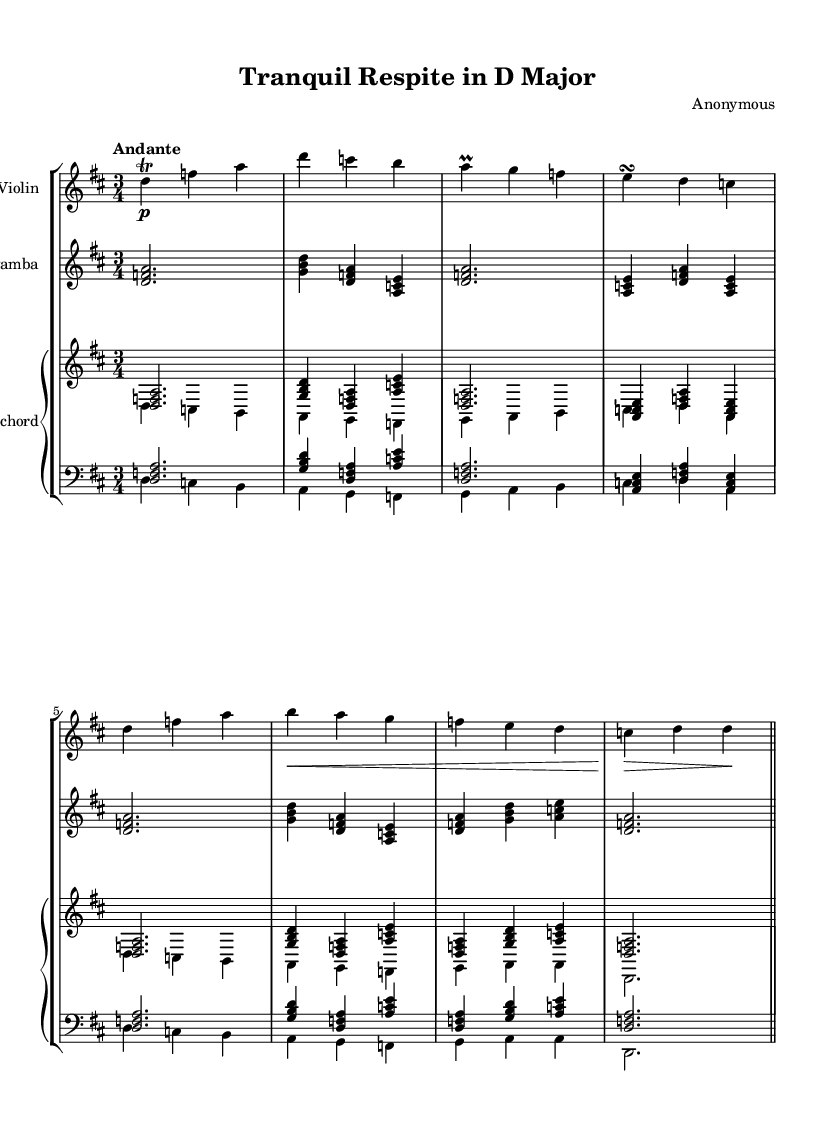What is the key signature of this music? The key signature is indicated at the beginning of the staff. It shows two sharps, which corresponds to the key of D major.
Answer: D major What is the time signature of this music? The time signature is written as a fraction at the beginning of the staff. It shows 3 over 4, indicating three beats in each measure with a quarter note receiving one beat.
Answer: 3/4 What is the tempo marking of this piece? The tempo marking is included above the staff and specifies the speed of the piece. It reads "Andante," indicating a moderate walking pace.
Answer: Andante How many staves are used for the instruments in this piece? The score contains three staves: one for the violin, one for the viola da gamba, and one piano staff with two staves for the harpsichord.
Answer: Three What instrument is indicated for the third staff? The instrument name is located above the staff. For the third staff, it specifies "Harpsichord."
Answer: Harpsichord Which type of harmony is commonly found in Baroque chamber music? In Baroque chamber music, composers often used figured bass for harmonic notation, providing a framework for improvisation. The score does not specify numbers directly but implies harmonic structure through chords.
Answer: Figured bass What is the dynamic marking for the violin part in the first measure? The dynamic marking is placed before the note in the first measure. It shows "p," which indicates to play the passage softly.
Answer: pianissimo 